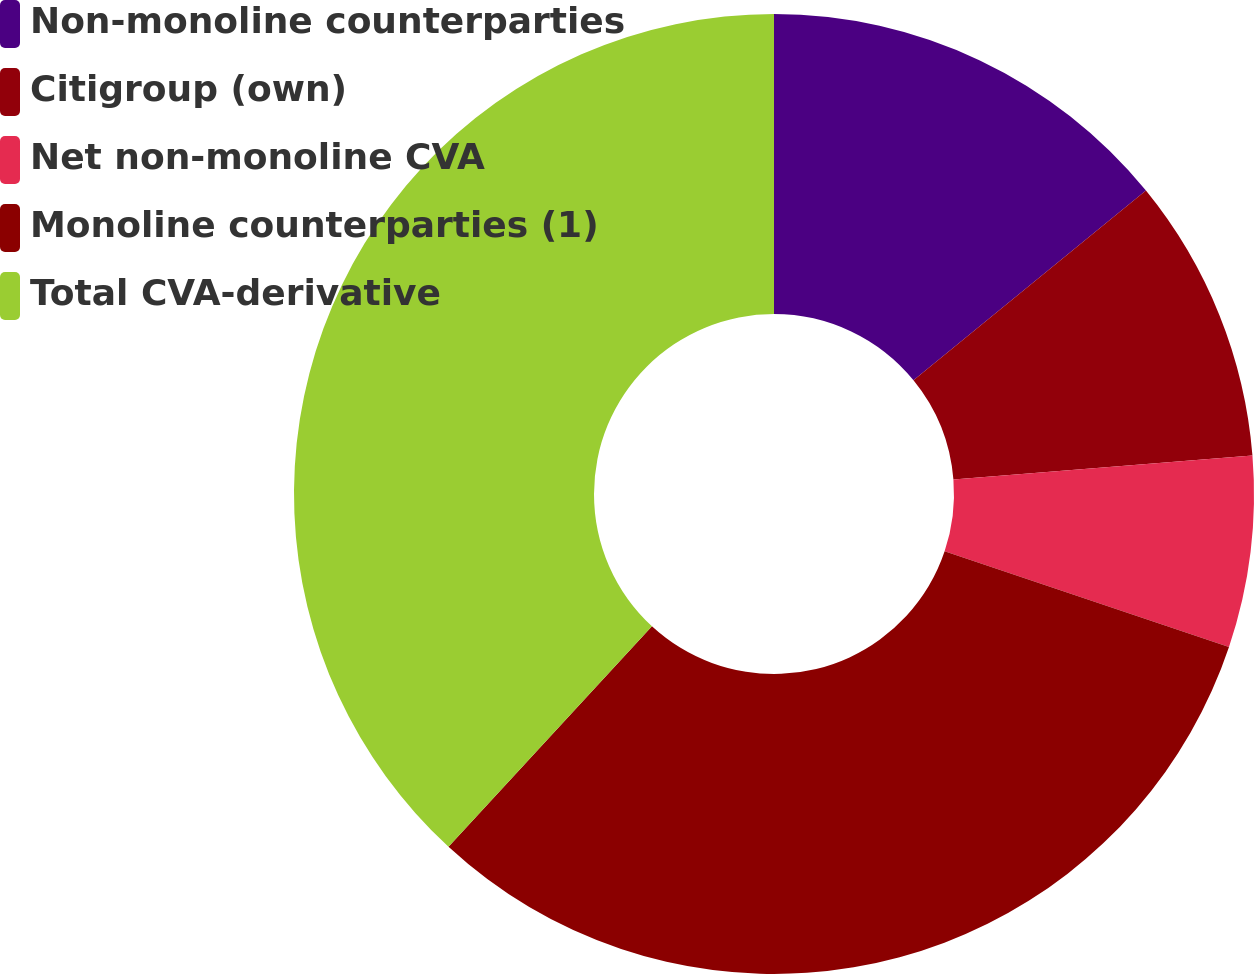Convert chart. <chart><loc_0><loc_0><loc_500><loc_500><pie_chart><fcel>Non-monoline counterparties<fcel>Citigroup (own)<fcel>Net non-monoline CVA<fcel>Monoline counterparties (1)<fcel>Total CVA-derivative<nl><fcel>14.11%<fcel>9.61%<fcel>6.44%<fcel>31.7%<fcel>38.14%<nl></chart> 